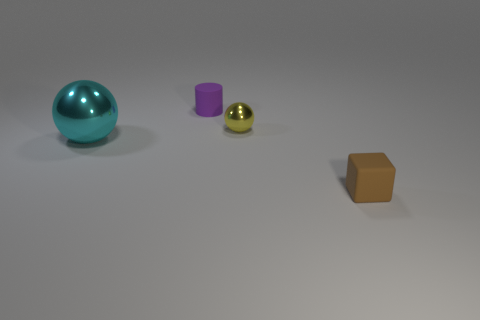Can you describe the lighting in this scene? The lighting appears to be soft and diffused, coming from the upper right, casting gentle shadows to the left of the objects, indicating a possibly overcast or indoor photo-shoot like environment. 